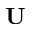Convert formula to latex. <formula><loc_0><loc_0><loc_500><loc_500>U</formula> 